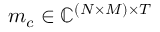<formula> <loc_0><loc_0><loc_500><loc_500>m _ { c } \in \mathbb { C } ^ { ( N \times M ) \times T }</formula> 